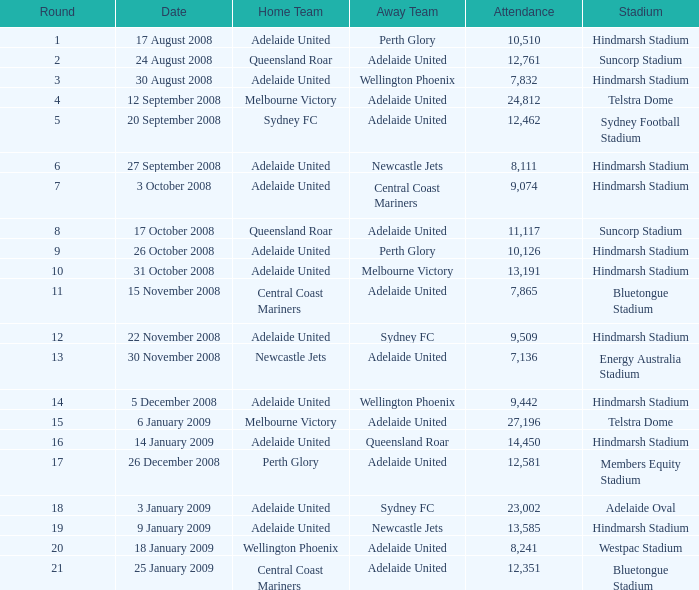What is the circular when 11,117 individuals were present at the match on 26 october 2008? 9.0. 